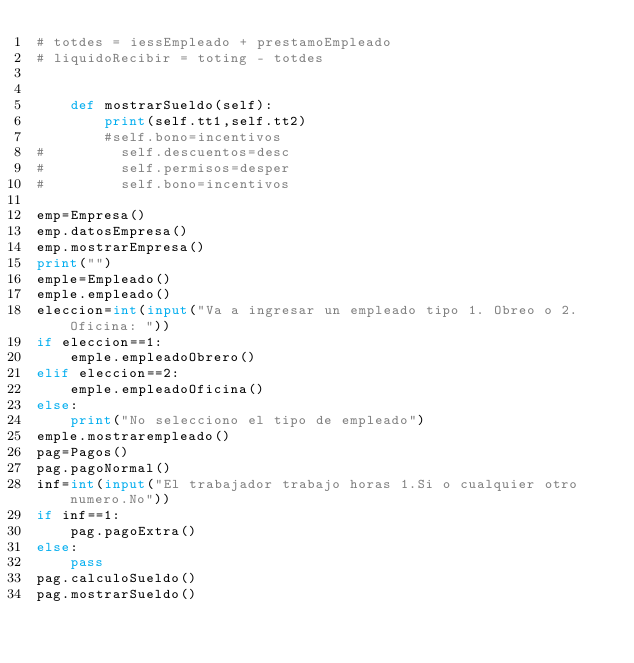<code> <loc_0><loc_0><loc_500><loc_500><_Python_># totdes = iessEmpleado + prestamoEmpleado
# liquidoRecibir = toting - totdes


    def mostrarSueldo(self):
        print(self.tt1,self.tt2)
        #self.bono=incentivos
#         self.descuentos=desc
#         self.permisos=desper
#         self.bono=incentivos

emp=Empresa()
emp.datosEmpresa()
emp.mostrarEmpresa()
print("")
emple=Empleado()
emple.empleado()
eleccion=int(input("Va a ingresar un empleado tipo 1. Obreo o 2.Oficina: "))
if eleccion==1:
    emple.empleadoObrero()
elif eleccion==2:
    emple.empleadoOficina()
else:
    print("No selecciono el tipo de empleado")
emple.mostrarempleado()
pag=Pagos()
pag.pagoNormal()
inf=int(input("El trabajador trabajo horas 1.Si o cualquier otro numero.No"))
if inf==1:
    pag.pagoExtra()
else:
    pass    
pag.calculoSueldo()
pag.mostrarSueldo()</code> 